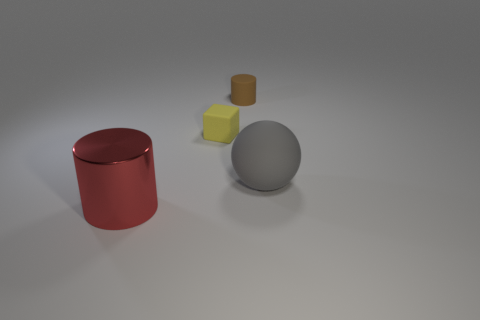Are there any other things that are the same shape as the big matte object?
Your response must be concise. No. There is a cylinder to the right of the small thing that is in front of the matte cylinder; what is its size?
Make the answer very short. Small. The small block that is made of the same material as the gray object is what color?
Make the answer very short. Yellow. How many brown cylinders are the same size as the brown rubber thing?
Provide a succinct answer. 0. What number of cyan things are either matte balls or tiny cylinders?
Make the answer very short. 0. How many things are either large brown matte balls or cylinders in front of the small yellow object?
Provide a short and direct response. 1. What material is the large object that is on the right side of the red metallic object?
Your answer should be very brief. Rubber. What shape is the gray matte object that is the same size as the red object?
Ensure brevity in your answer.  Sphere. Are there any other gray things of the same shape as the shiny thing?
Ensure brevity in your answer.  No. Do the large gray object and the object that is left of the cube have the same material?
Ensure brevity in your answer.  No. 